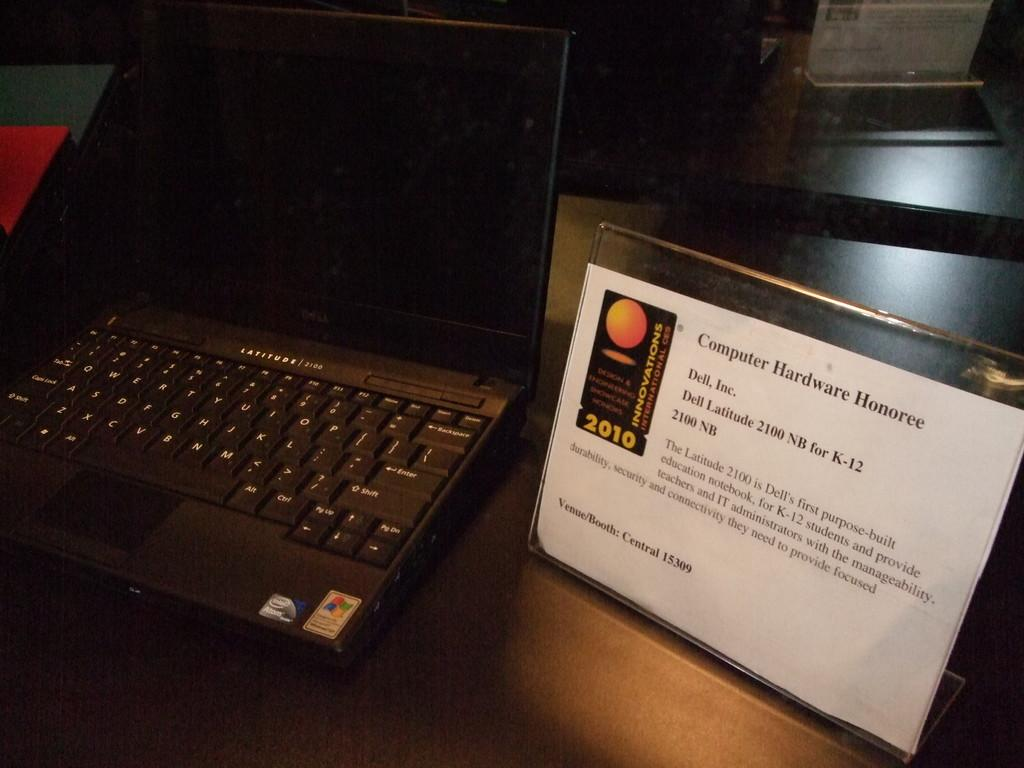Provide a one-sentence caption for the provided image. An award sits beside a laptop for a computer hardware Honoree in 2010. 